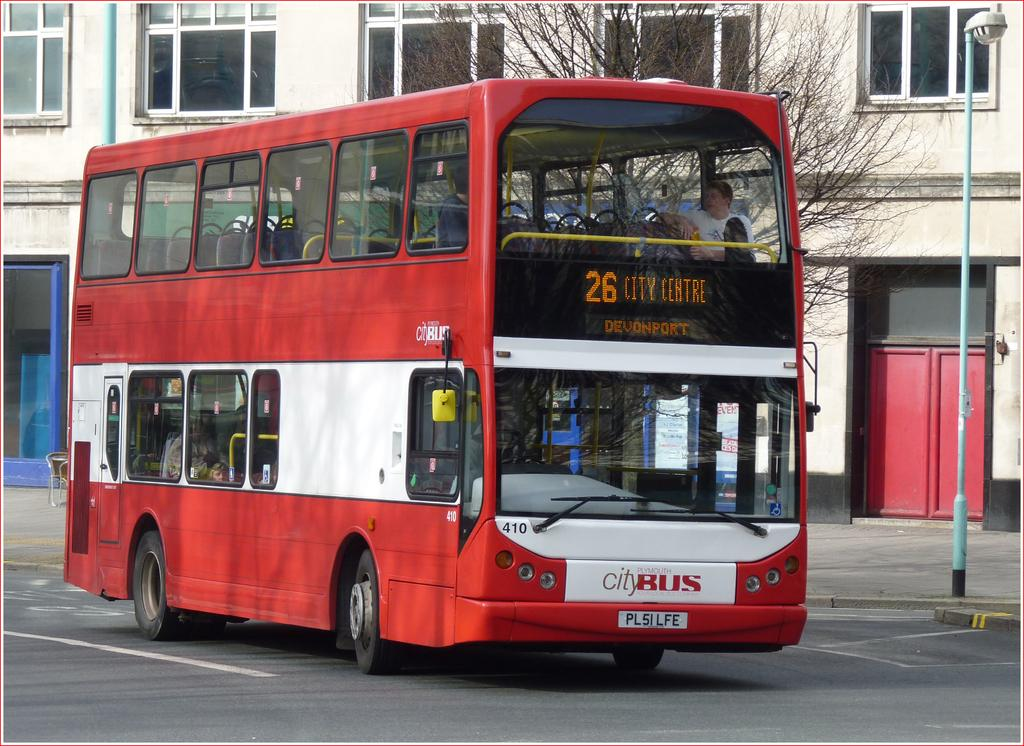What type of vehicle is on the road in the image? There is a bus on the road in the image. Who or what is inside the bus? There are people inside the bus. What can be seen near the bus? There is a pole in the image. What is attached to the pole? There is a street lamp attached to the pole. What other objects can be seen in the image? There is a tree and a building with windows and doors in the background of the image. What is the increase in temperature during winter in the image? There is no information about the temperature or season in the image, so it cannot be determined. 